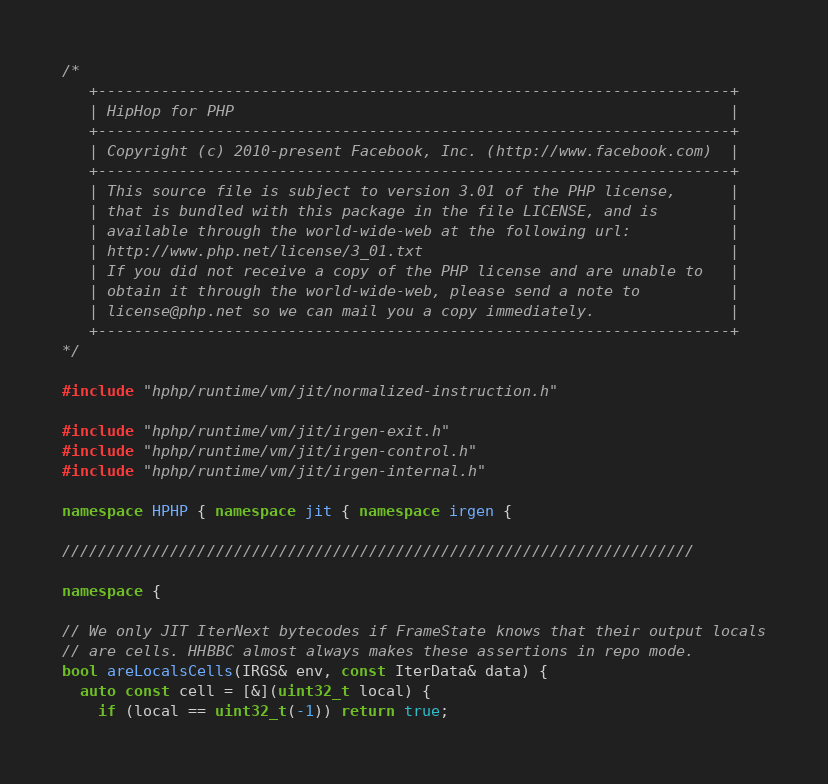Convert code to text. <code><loc_0><loc_0><loc_500><loc_500><_C++_>/*
   +----------------------------------------------------------------------+
   | HipHop for PHP                                                       |
   +----------------------------------------------------------------------+
   | Copyright (c) 2010-present Facebook, Inc. (http://www.facebook.com)  |
   +----------------------------------------------------------------------+
   | This source file is subject to version 3.01 of the PHP license,      |
   | that is bundled with this package in the file LICENSE, and is        |
   | available through the world-wide-web at the following url:           |
   | http://www.php.net/license/3_01.txt                                  |
   | If you did not receive a copy of the PHP license and are unable to   |
   | obtain it through the world-wide-web, please send a note to          |
   | license@php.net so we can mail you a copy immediately.               |
   +----------------------------------------------------------------------+
*/

#include "hphp/runtime/vm/jit/normalized-instruction.h"

#include "hphp/runtime/vm/jit/irgen-exit.h"
#include "hphp/runtime/vm/jit/irgen-control.h"
#include "hphp/runtime/vm/jit/irgen-internal.h"

namespace HPHP { namespace jit { namespace irgen {

//////////////////////////////////////////////////////////////////////

namespace {

// We only JIT IterNext bytecodes if FrameState knows that their output locals
// are cells. HHBBC almost always makes these assertions in repo mode.
bool areLocalsCells(IRGS& env, const IterData& data) {
  auto const cell = [&](uint32_t local) {
    if (local == uint32_t(-1)) return true;</code> 